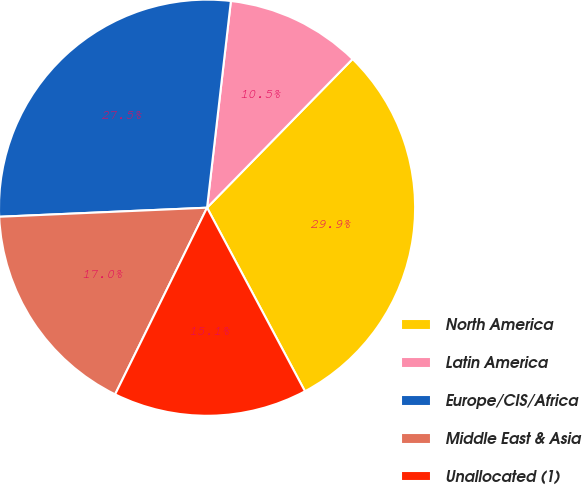Convert chart. <chart><loc_0><loc_0><loc_500><loc_500><pie_chart><fcel>North America<fcel>Latin America<fcel>Europe/CIS/Africa<fcel>Middle East & Asia<fcel>Unallocated (1)<nl><fcel>29.87%<fcel>10.5%<fcel>27.52%<fcel>17.02%<fcel>15.08%<nl></chart> 